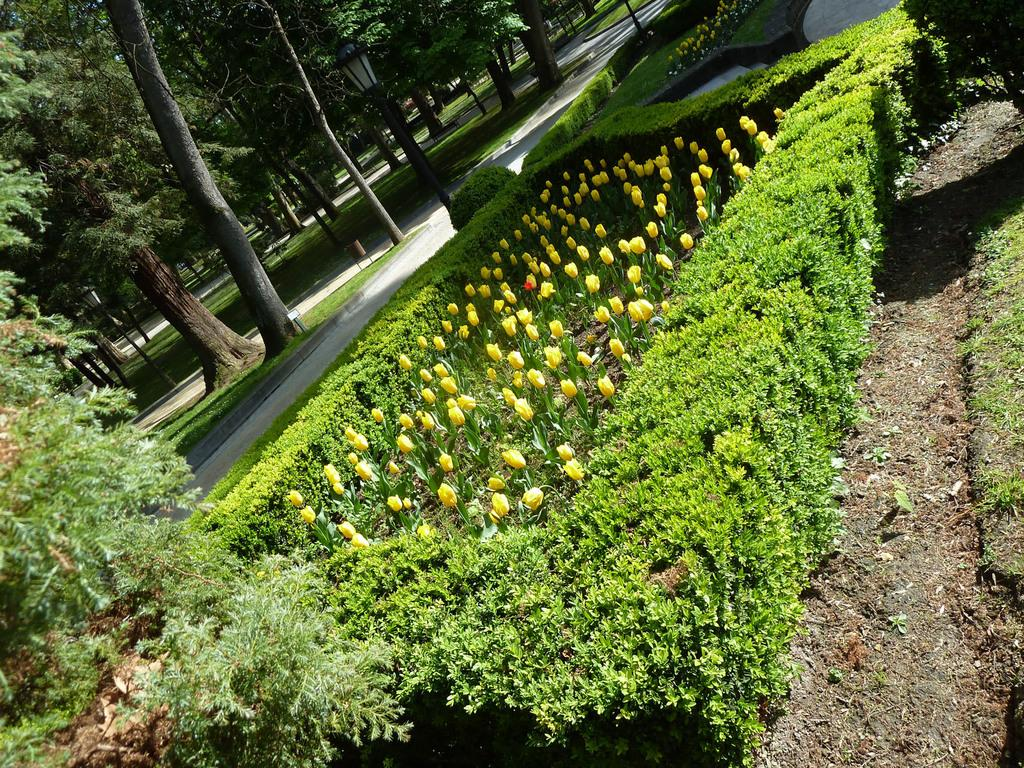What type of vegetation can be seen in the image? There are plants, grass, and trees in the image. Can you describe the flowers in the image? There are yellow tulip flowers in the image. What type of man-made structure is present in the image? There is a road and poles with lights in the image. How does the fog affect the visibility of the planes in the image? There are no planes or fog present in the image. What type of police presence can be seen in the image? There is no police presence in the image. 